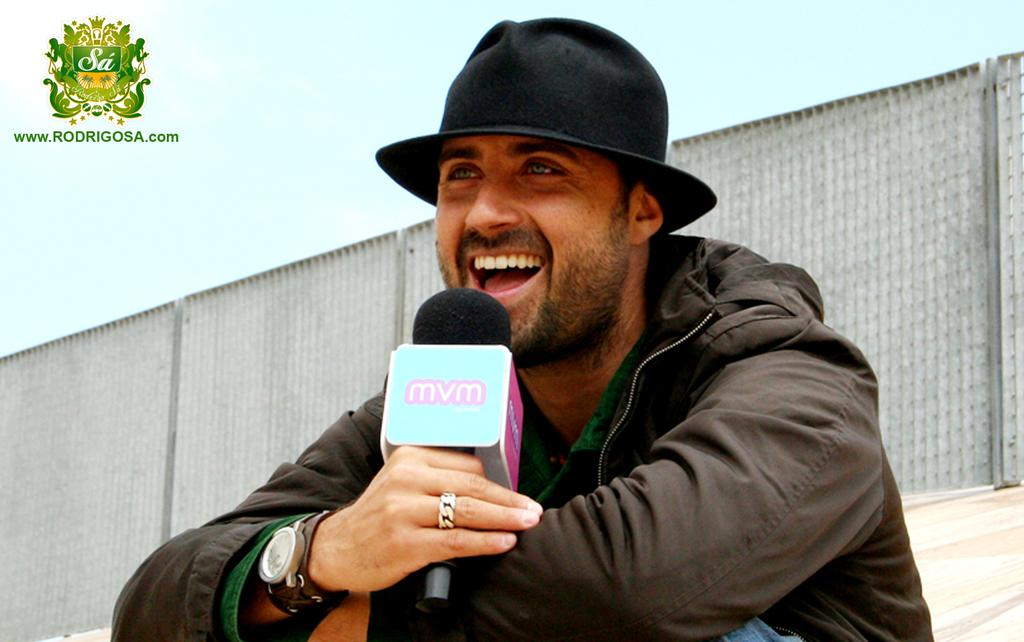What is the man in the image holding in his hand? The man is holding a mic in his hand. What is the man's facial expression in the image? The man is smiling in the image. What is the man wearing on his head? The man is wearing a hat in the image. What can be seen in the background of the image? There is a fence and a wall in the background of the image. What type of cart is visible in the image? There is no cart present in the image. What is the tin used for in the image? There is no tin present in the image. 